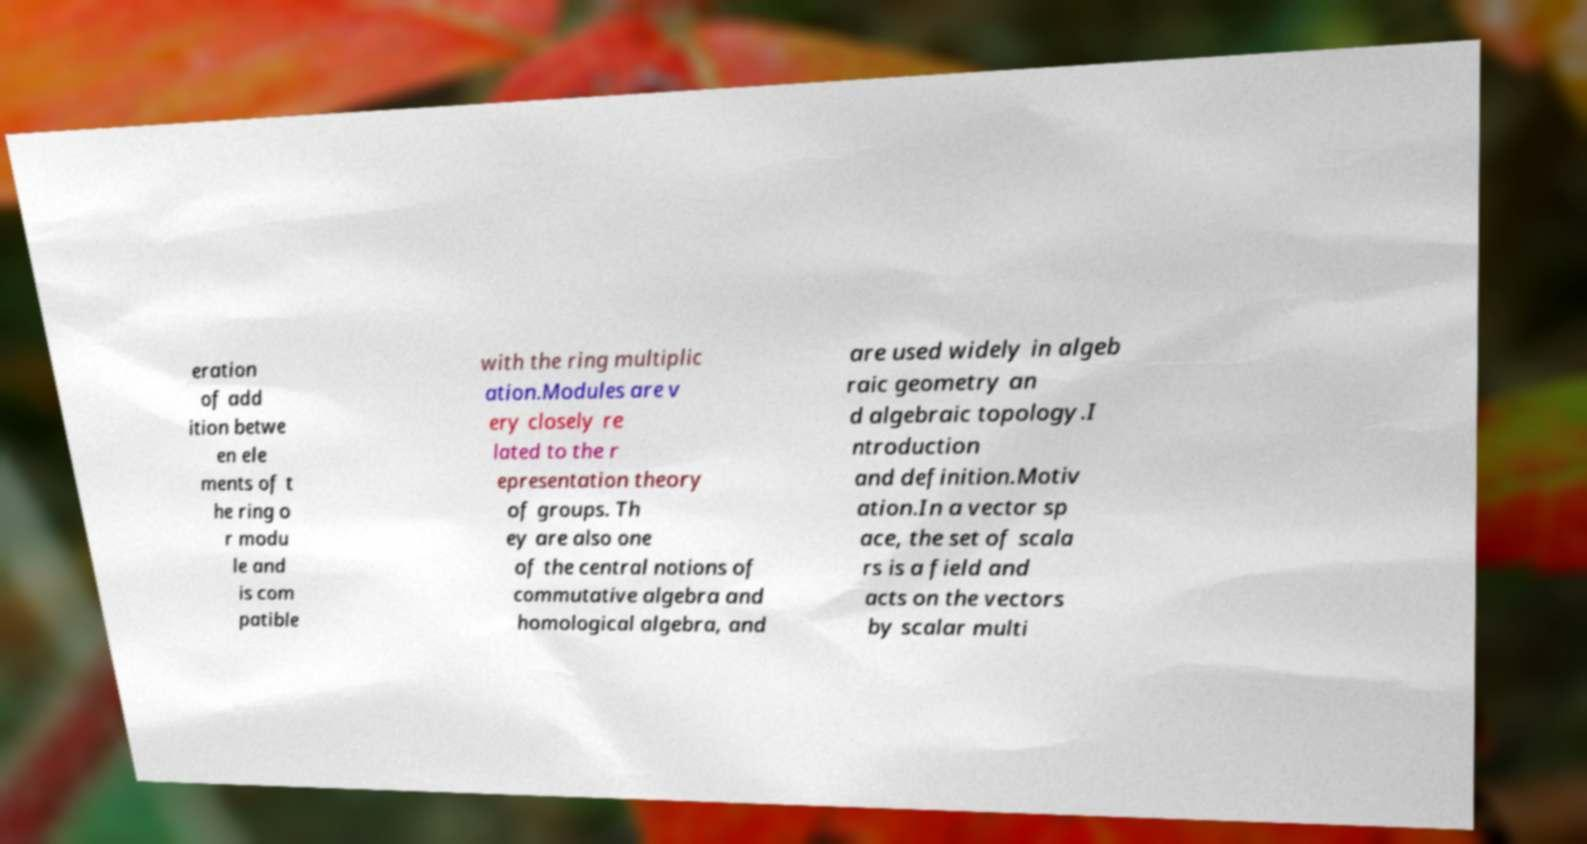Please identify and transcribe the text found in this image. eration of add ition betwe en ele ments of t he ring o r modu le and is com patible with the ring multiplic ation.Modules are v ery closely re lated to the r epresentation theory of groups. Th ey are also one of the central notions of commutative algebra and homological algebra, and are used widely in algeb raic geometry an d algebraic topology.I ntroduction and definition.Motiv ation.In a vector sp ace, the set of scala rs is a field and acts on the vectors by scalar multi 